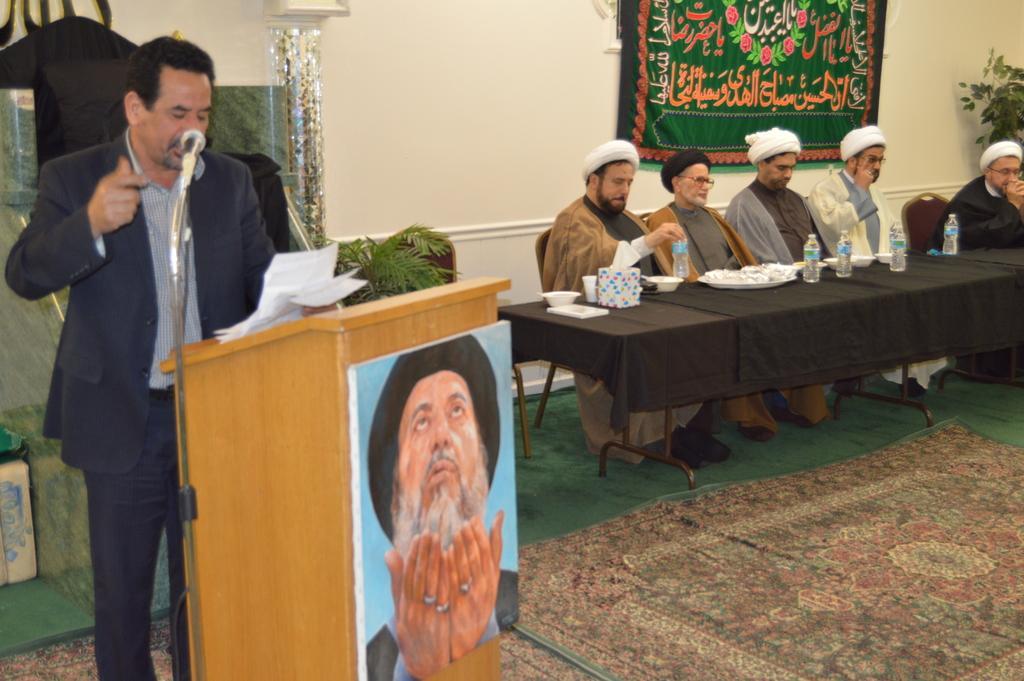How would you summarize this image in a sentence or two? In this image, there is an inside view of a building. On the left side of the image, there is person standing in front of the mic and podium. This person is wearing clothes and holding some papers with his hand. There are some person on the right side of the image sitting in front of the table. This table is covered with a cloth and contains some bottles and plates. There is a carpet on the ground. There is a banner in the top right of the image. 